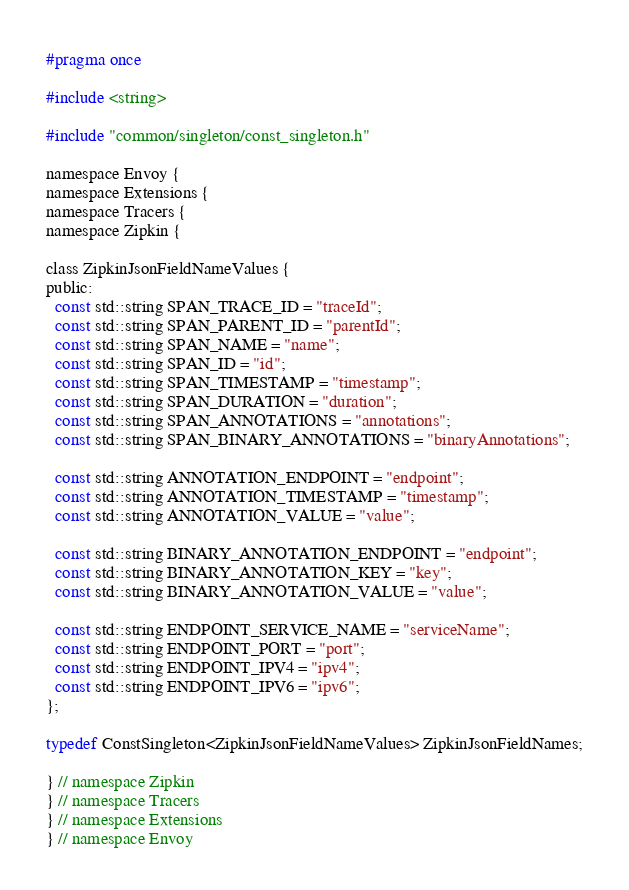Convert code to text. <code><loc_0><loc_0><loc_500><loc_500><_C_>#pragma once

#include <string>

#include "common/singleton/const_singleton.h"

namespace Envoy {
namespace Extensions {
namespace Tracers {
namespace Zipkin {

class ZipkinJsonFieldNameValues {
public:
  const std::string SPAN_TRACE_ID = "traceId";
  const std::string SPAN_PARENT_ID = "parentId";
  const std::string SPAN_NAME = "name";
  const std::string SPAN_ID = "id";
  const std::string SPAN_TIMESTAMP = "timestamp";
  const std::string SPAN_DURATION = "duration";
  const std::string SPAN_ANNOTATIONS = "annotations";
  const std::string SPAN_BINARY_ANNOTATIONS = "binaryAnnotations";

  const std::string ANNOTATION_ENDPOINT = "endpoint";
  const std::string ANNOTATION_TIMESTAMP = "timestamp";
  const std::string ANNOTATION_VALUE = "value";

  const std::string BINARY_ANNOTATION_ENDPOINT = "endpoint";
  const std::string BINARY_ANNOTATION_KEY = "key";
  const std::string BINARY_ANNOTATION_VALUE = "value";

  const std::string ENDPOINT_SERVICE_NAME = "serviceName";
  const std::string ENDPOINT_PORT = "port";
  const std::string ENDPOINT_IPV4 = "ipv4";
  const std::string ENDPOINT_IPV6 = "ipv6";
};

typedef ConstSingleton<ZipkinJsonFieldNameValues> ZipkinJsonFieldNames;

} // namespace Zipkin
} // namespace Tracers
} // namespace Extensions
} // namespace Envoy
</code> 